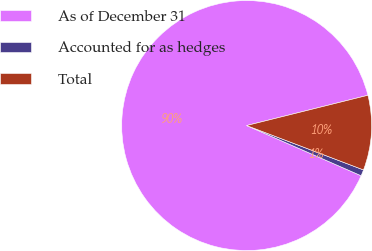<chart> <loc_0><loc_0><loc_500><loc_500><pie_chart><fcel>As of December 31<fcel>Accounted for as hedges<fcel>Total<nl><fcel>89.53%<fcel>0.8%<fcel>9.67%<nl></chart> 